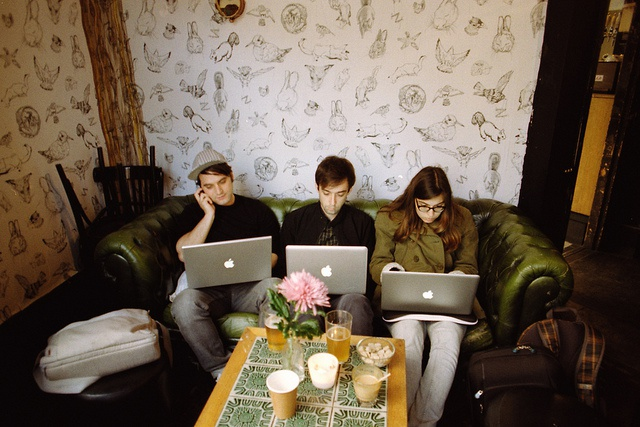Describe the objects in this image and their specific colors. I can see couch in olive, black, and darkgray tones, people in olive, black, maroon, and darkgray tones, people in olive, black, maroon, gray, and tan tones, people in olive, black, tan, and darkgray tones, and backpack in olive, black, maroon, and brown tones in this image. 